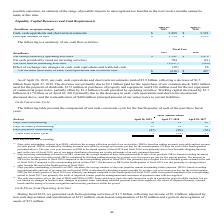According to Netapp's financial document, How was Days sales outstanding calculated? dividing accounts receivable by average net revenue per day for the current quarter (91 days for each of the fourth quarters presented above). The document states: "net revenue for each period. DSO is calculated by dividing accounts receivable by average net revenue per day for the current quarter (91 days for eac..." Also, What was days inventory outstanding based on? ending inventory and cost of revenues for each period.. The document states: "ocurement to sale of our products. DIO is based on ending inventory and cost of revenues for each period. DIO is calculated by dividing ending invento..." Also, What was the Days sales outstanding for three months ended april 2019? According to the financial document, 70. The relevant text states: "Days sales outstanding (1) 70 58 45..." Also, can you calculate: What was the change in day sales outstanding between 2018 and 2019? Based on the calculation: 70-58, the result is 12. This is based on the information: "Days sales outstanding (1) 70 58 45 Days sales outstanding (1) 70 58 45..." The key data points involved are: 58, 70. Also, How many years did days inventory outstanding exceed 20 days? Counting the relevant items in the document: 2019, 2017, I find 2 instances. The key data points involved are: 2017, 2019. Also, can you calculate: What was the total percentage change in the cash conversion cycle between 2017 and 2019? To answer this question, I need to perform calculations using the financial data. The calculation is: (3-15)/15, which equals -80 (percentage). This is based on the information: "Cash conversion cycle (4) 3 (14 ) 15 Cash conversion cycle (4) 3 (14 ) 15..." The key data points involved are: 15, 3. 